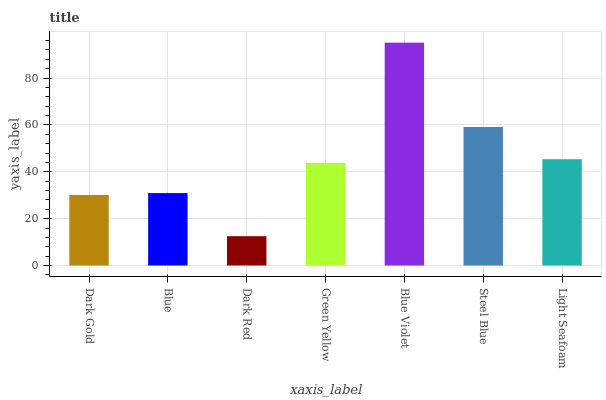Is Dark Red the minimum?
Answer yes or no. Yes. Is Blue Violet the maximum?
Answer yes or no. Yes. Is Blue the minimum?
Answer yes or no. No. Is Blue the maximum?
Answer yes or no. No. Is Blue greater than Dark Gold?
Answer yes or no. Yes. Is Dark Gold less than Blue?
Answer yes or no. Yes. Is Dark Gold greater than Blue?
Answer yes or no. No. Is Blue less than Dark Gold?
Answer yes or no. No. Is Green Yellow the high median?
Answer yes or no. Yes. Is Green Yellow the low median?
Answer yes or no. Yes. Is Blue Violet the high median?
Answer yes or no. No. Is Blue Violet the low median?
Answer yes or no. No. 